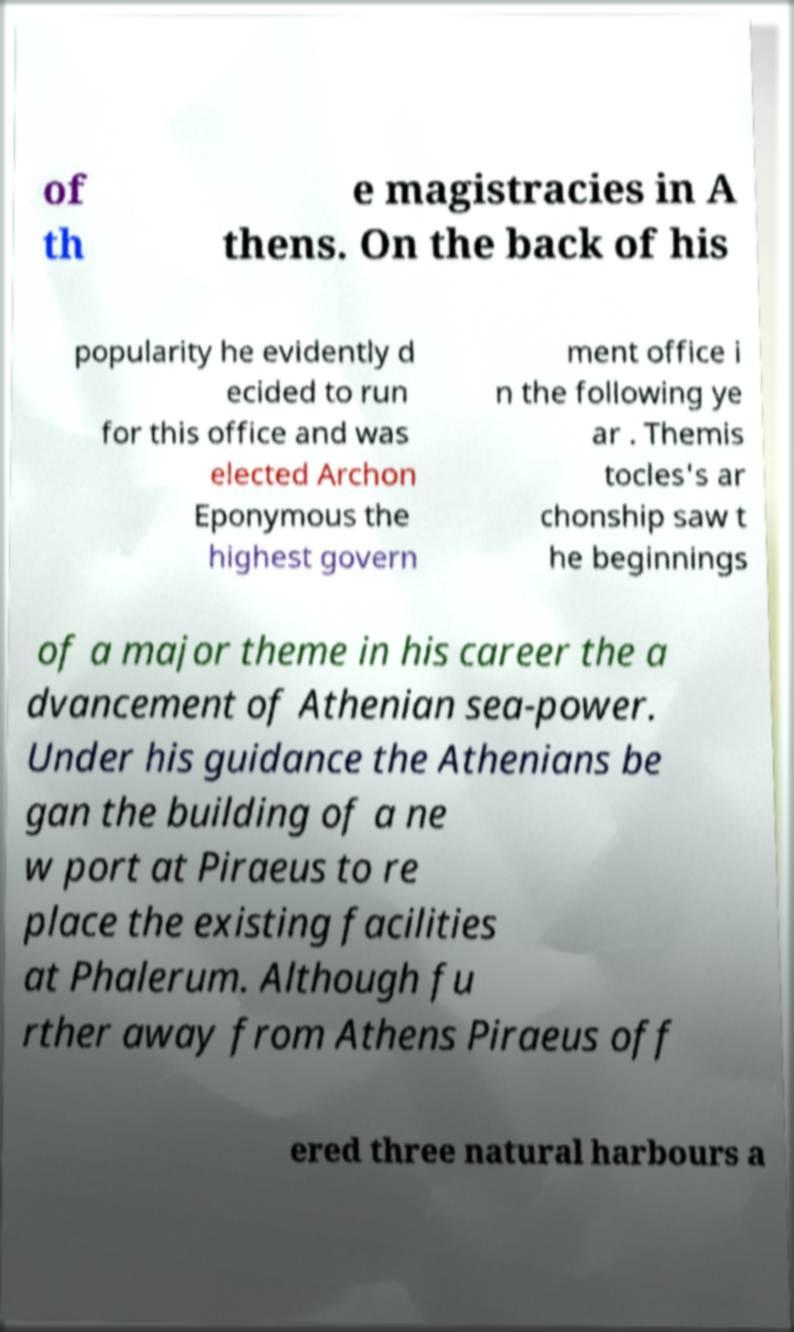I need the written content from this picture converted into text. Can you do that? of th e magistracies in A thens. On the back of his popularity he evidently d ecided to run for this office and was elected Archon Eponymous the highest govern ment office i n the following ye ar . Themis tocles's ar chonship saw t he beginnings of a major theme in his career the a dvancement of Athenian sea-power. Under his guidance the Athenians be gan the building of a ne w port at Piraeus to re place the existing facilities at Phalerum. Although fu rther away from Athens Piraeus off ered three natural harbours a 